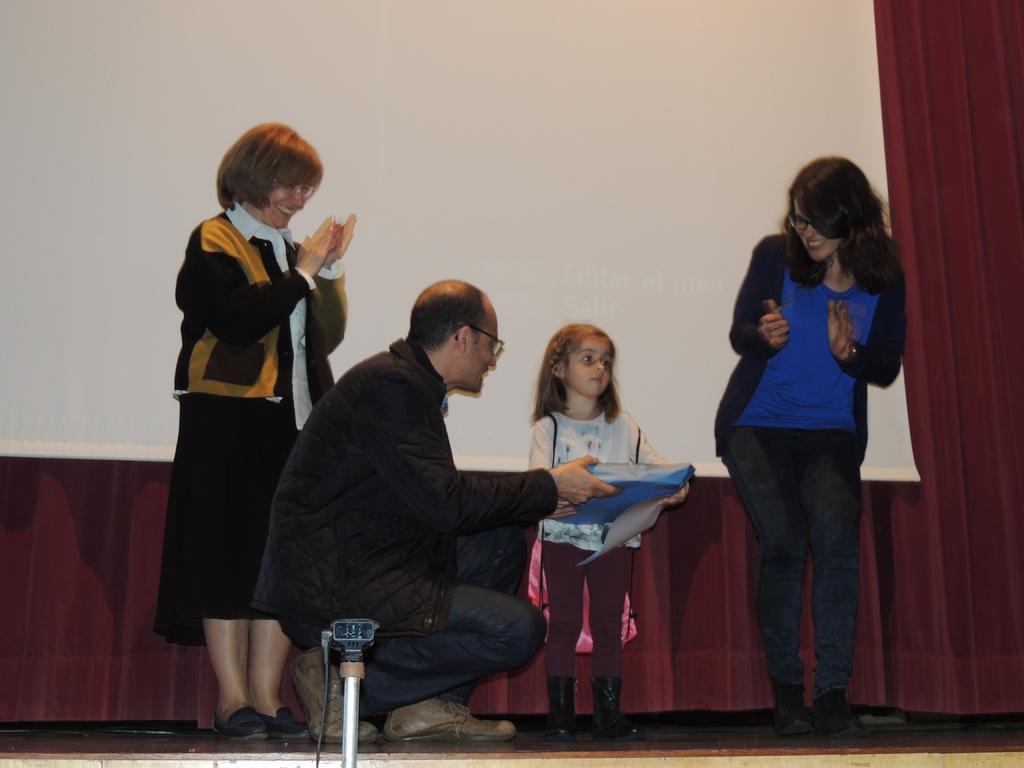Describe this image in one or two sentences. In this image we can see persons standing on the floor. In the background we can see curtains and a screen. 